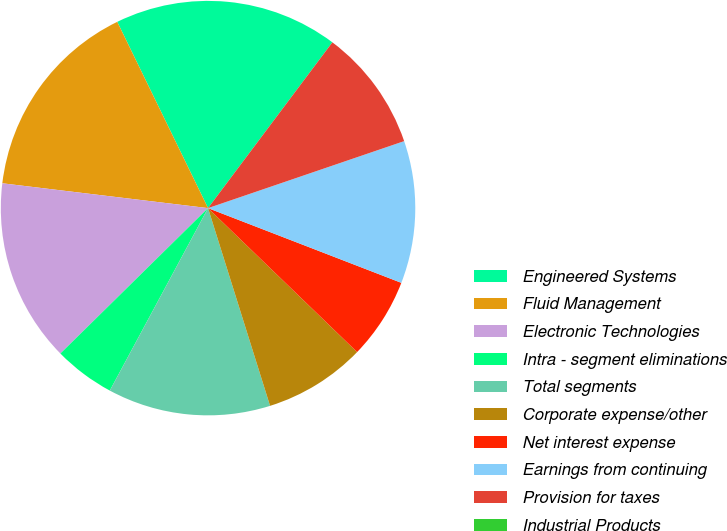<chart> <loc_0><loc_0><loc_500><loc_500><pie_chart><fcel>Engineered Systems<fcel>Fluid Management<fcel>Electronic Technologies<fcel>Intra - segment eliminations<fcel>Total segments<fcel>Corporate expense/other<fcel>Net interest expense<fcel>Earnings from continuing<fcel>Provision for taxes<fcel>Industrial Products<nl><fcel>17.46%<fcel>15.87%<fcel>14.29%<fcel>4.76%<fcel>12.7%<fcel>7.94%<fcel>6.35%<fcel>11.11%<fcel>9.52%<fcel>0.0%<nl></chart> 